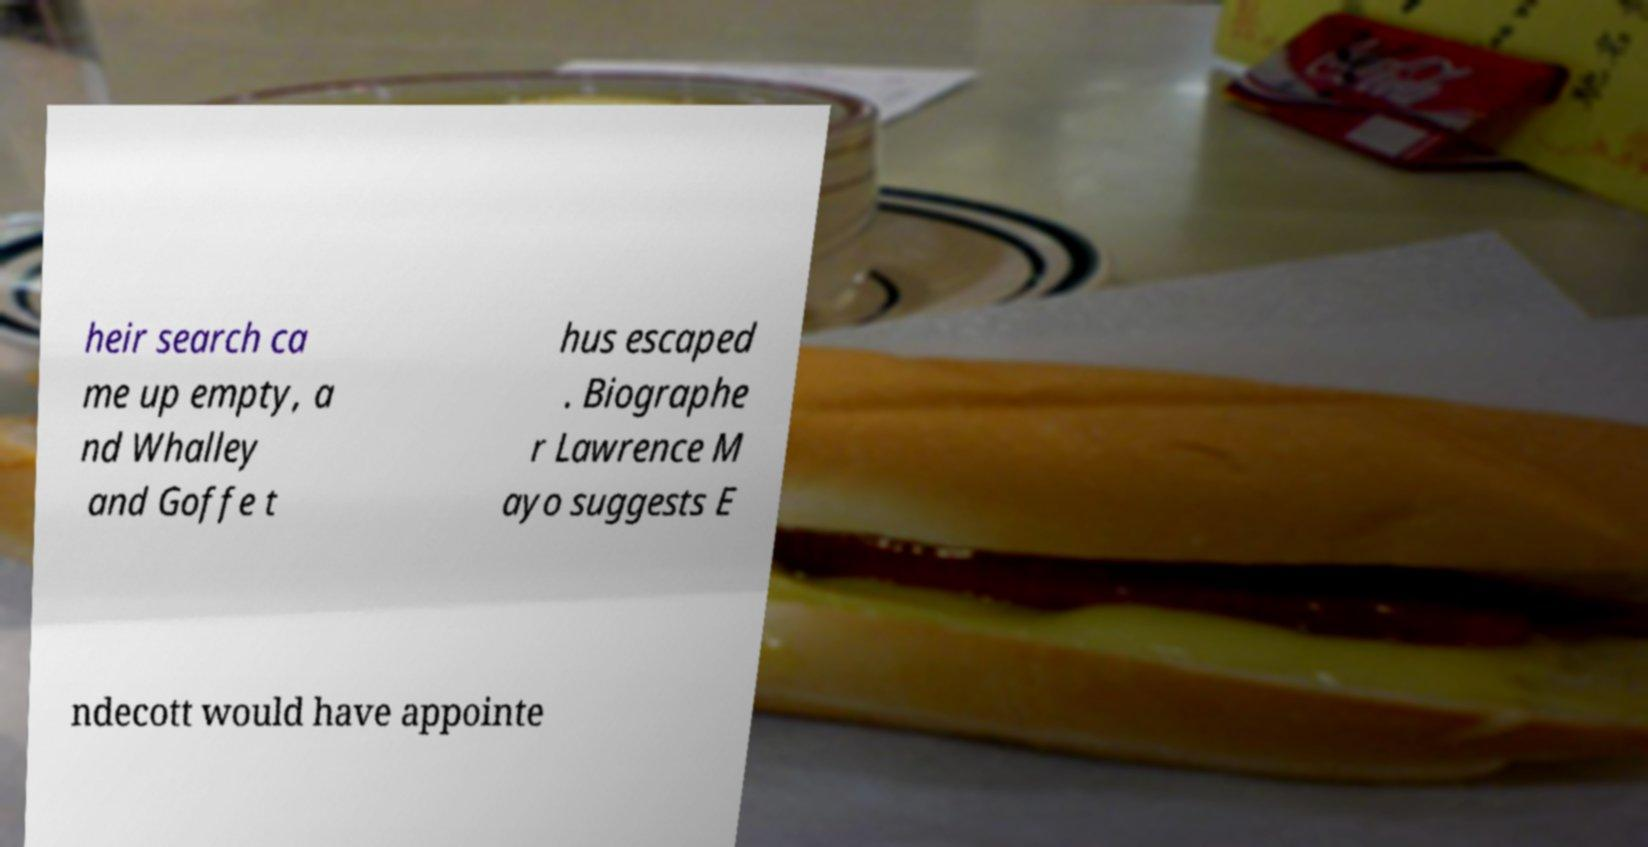Can you read and provide the text displayed in the image?This photo seems to have some interesting text. Can you extract and type it out for me? heir search ca me up empty, a nd Whalley and Goffe t hus escaped . Biographe r Lawrence M ayo suggests E ndecott would have appointe 